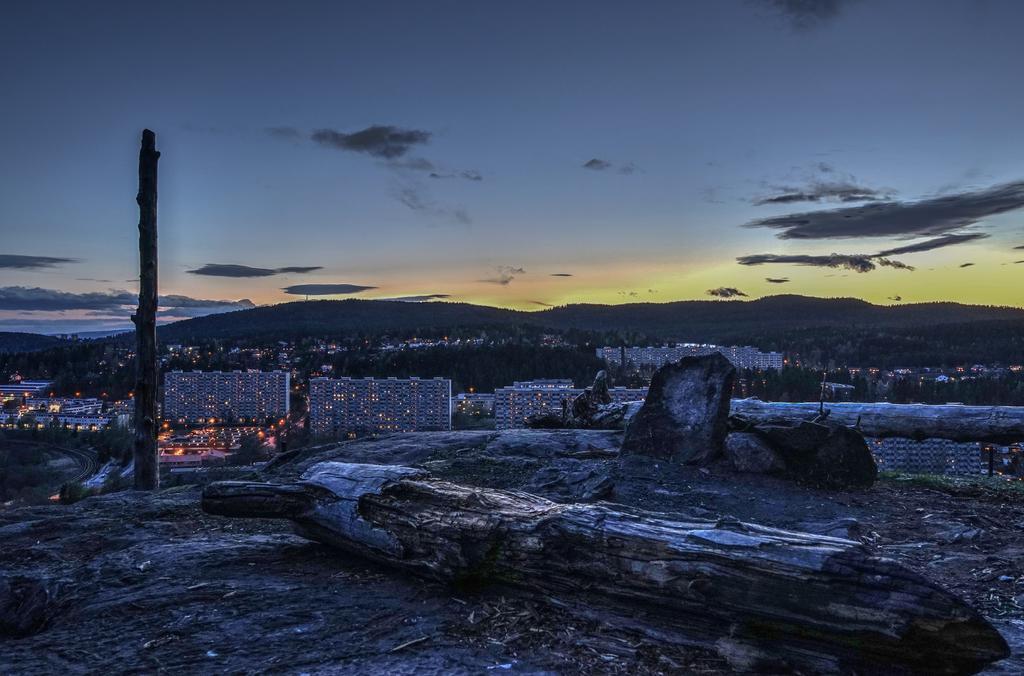Could you give a brief overview of what you see in this image? In this image in the center there is a wooden log on the floor which is in the front. In the background there are buildings, there are trees and there are mountains and the sky is cloudy. 